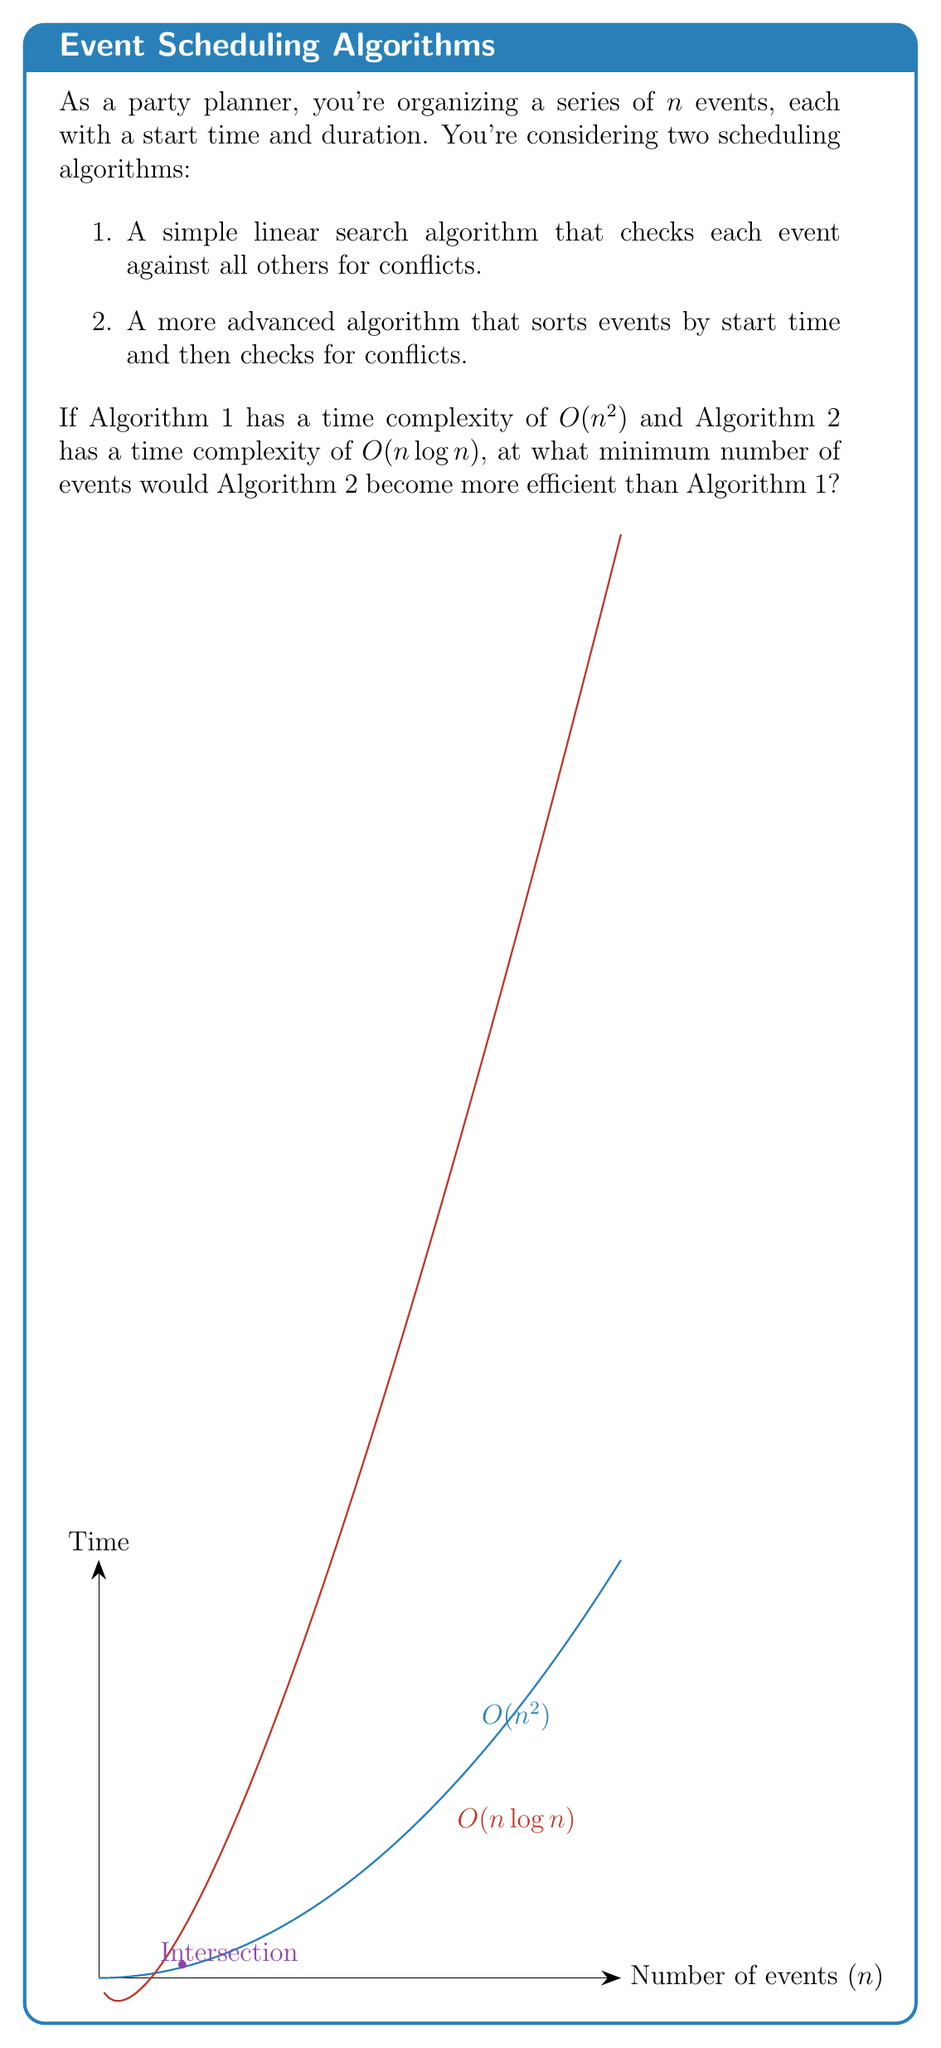Solve this math problem. To find the point where Algorithm 2 becomes more efficient, we need to find the value of $n$ where the time complexities are equal:

1) Set up the equation:
   $n^2 = n \log n$

2) Divide both sides by $n$:
   $n = \log n$

3) This equation can't be solved algebraically, so we need to use numerical methods or estimation.

4) We can see that when $n = 2$, the left side (2) is greater than the right side ($\log 2 \approx 0.69$).

5) When $n = 4$, the left side (4) is still greater than the right side ($\log 4 = 2$).

6) When $n = 8$, the left side (8) is less than the right side ($\log 8 = 3$).

7) Therefore, the intersection point is between 4 and 8.

8) By trial and error or using a calculator, we can find that the equation is satisfied when $n \approx 4.768$.

9) Since we're looking for the minimum number of events, and $n$ must be a whole number, we round up to 5.

Therefore, Algorithm 2 becomes more efficient when there are 5 or more events to schedule.
Answer: 5 events 